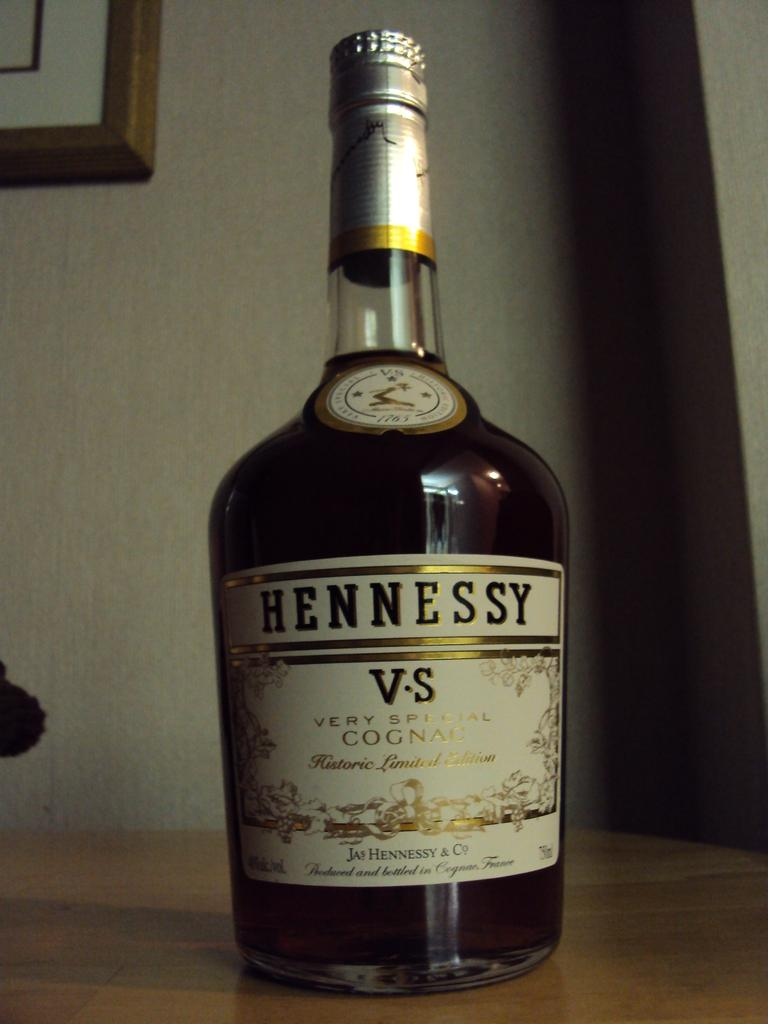<image>
Create a compact narrative representing the image presented. A bottle of Hennessy very special Cognac sits on a wooden table. 